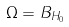Convert formula to latex. <formula><loc_0><loc_0><loc_500><loc_500>\Omega = B _ { H _ { 0 } } \,</formula> 